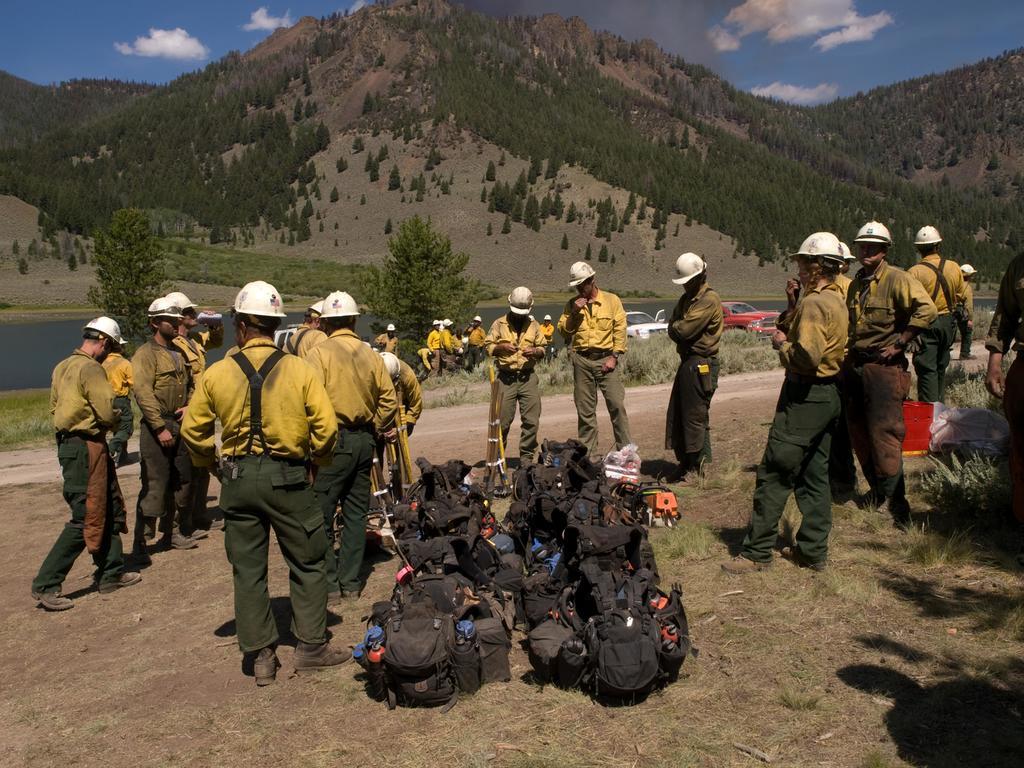Can you describe this image briefly? This picture shows few people are standing and they wore caps on their heads and few vehicles parked and we see few backpacks on the ground and we see trees on Hills and a blue cloudy Sky and we see water and grass on the ground. 